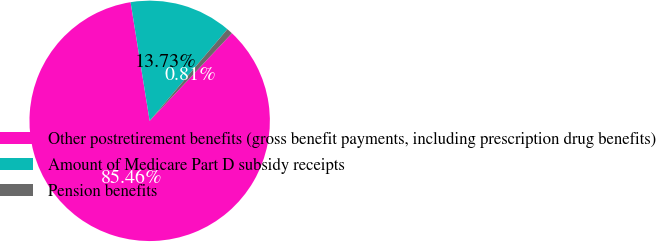Convert chart. <chart><loc_0><loc_0><loc_500><loc_500><pie_chart><fcel>Other postretirement benefits (gross benefit payments, including prescription drug benefits)<fcel>Amount of Medicare Part D subsidy receipts<fcel>Pension benefits<nl><fcel>85.46%<fcel>13.73%<fcel>0.81%<nl></chart> 